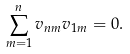<formula> <loc_0><loc_0><loc_500><loc_500>\sum _ { m = 1 } ^ { n } v _ { n m } v _ { 1 m } = 0 .</formula> 